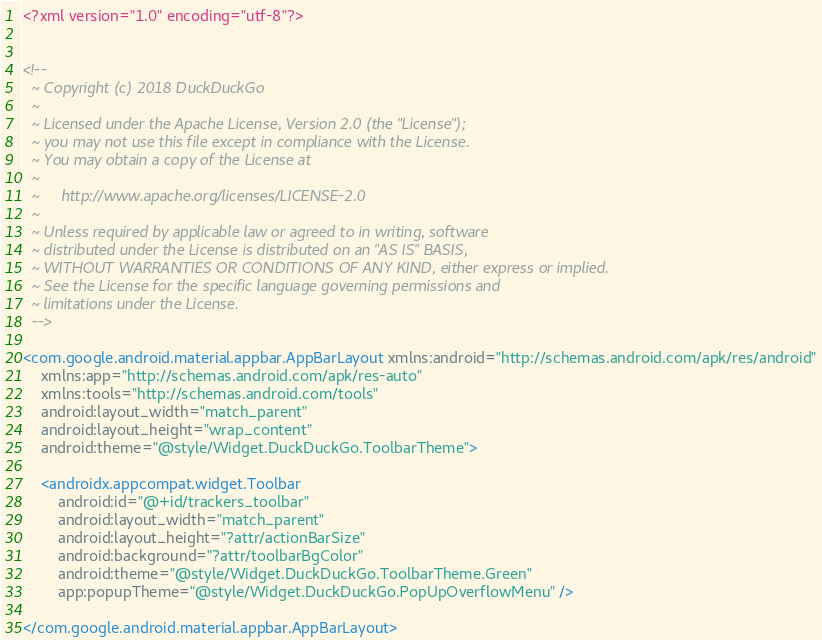Convert code to text. <code><loc_0><loc_0><loc_500><loc_500><_XML_><?xml version="1.0" encoding="utf-8"?>


<!--
  ~ Copyright (c) 2018 DuckDuckGo
  ~
  ~ Licensed under the Apache License, Version 2.0 (the "License");
  ~ you may not use this file except in compliance with the License.
  ~ You may obtain a copy of the License at
  ~
  ~     http://www.apache.org/licenses/LICENSE-2.0
  ~
  ~ Unless required by applicable law or agreed to in writing, software
  ~ distributed under the License is distributed on an "AS IS" BASIS,
  ~ WITHOUT WARRANTIES OR CONDITIONS OF ANY KIND, either express or implied.
  ~ See the License for the specific language governing permissions and
  ~ limitations under the License.
  -->

<com.google.android.material.appbar.AppBarLayout xmlns:android="http://schemas.android.com/apk/res/android"
    xmlns:app="http://schemas.android.com/apk/res-auto"
    xmlns:tools="http://schemas.android.com/tools"
    android:layout_width="match_parent"
    android:layout_height="wrap_content"
    android:theme="@style/Widget.DuckDuckGo.ToolbarTheme">

    <androidx.appcompat.widget.Toolbar
        android:id="@+id/trackers_toolbar"
        android:layout_width="match_parent"
        android:layout_height="?attr/actionBarSize"
        android:background="?attr/toolbarBgColor"
        android:theme="@style/Widget.DuckDuckGo.ToolbarTheme.Green"
        app:popupTheme="@style/Widget.DuckDuckGo.PopUpOverflowMenu" />

</com.google.android.material.appbar.AppBarLayout>

</code> 